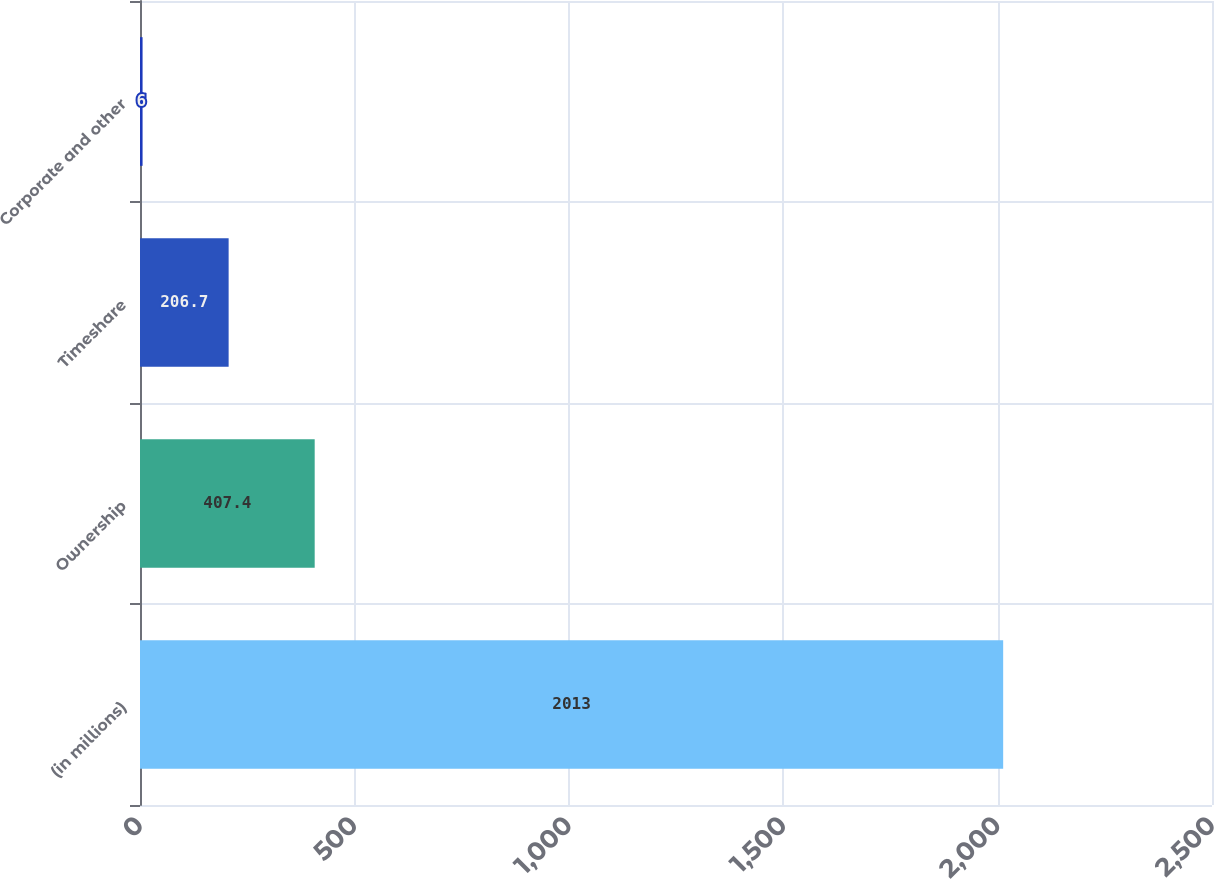Convert chart. <chart><loc_0><loc_0><loc_500><loc_500><bar_chart><fcel>(in millions)<fcel>Ownership<fcel>Timeshare<fcel>Corporate and other<nl><fcel>2013<fcel>407.4<fcel>206.7<fcel>6<nl></chart> 